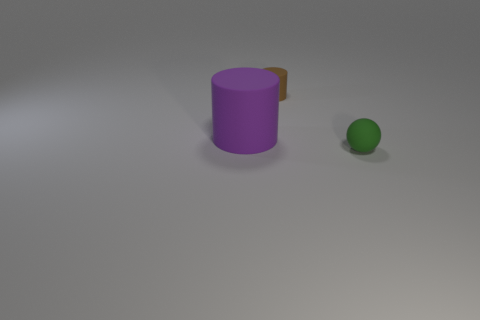Is there any other thing that is the same size as the purple matte thing?
Your answer should be compact. No. The large object is what shape?
Make the answer very short. Cylinder. What number of big yellow things are there?
Give a very brief answer. 0. What is the color of the small matte object that is behind the tiny object in front of the small brown cylinder?
Ensure brevity in your answer.  Brown. What is the color of the rubber thing that is the same size as the green matte sphere?
Offer a very short reply. Brown. Are there any small brown metallic balls?
Offer a terse response. No. What is the shape of the small object behind the tiny green thing?
Your answer should be very brief. Cylinder. What number of matte things are to the right of the large cylinder and left of the small green matte thing?
Your answer should be compact. 1. What number of other objects are there of the same size as the purple object?
Give a very brief answer. 0. There is a small object left of the small ball; does it have the same shape as the matte thing that is left of the tiny brown matte thing?
Ensure brevity in your answer.  Yes. 